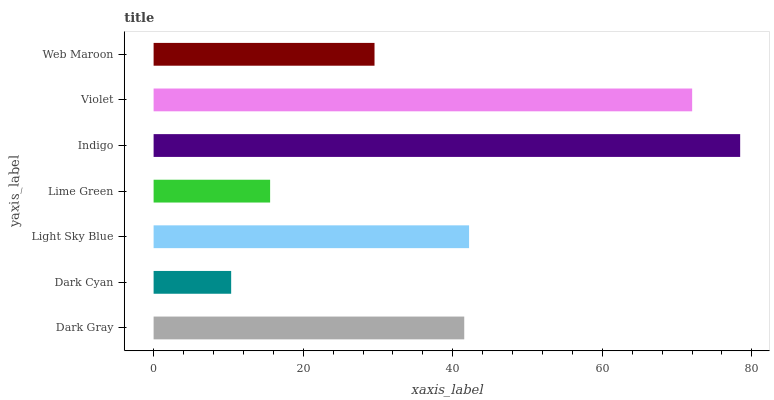Is Dark Cyan the minimum?
Answer yes or no. Yes. Is Indigo the maximum?
Answer yes or no. Yes. Is Light Sky Blue the minimum?
Answer yes or no. No. Is Light Sky Blue the maximum?
Answer yes or no. No. Is Light Sky Blue greater than Dark Cyan?
Answer yes or no. Yes. Is Dark Cyan less than Light Sky Blue?
Answer yes or no. Yes. Is Dark Cyan greater than Light Sky Blue?
Answer yes or no. No. Is Light Sky Blue less than Dark Cyan?
Answer yes or no. No. Is Dark Gray the high median?
Answer yes or no. Yes. Is Dark Gray the low median?
Answer yes or no. Yes. Is Violet the high median?
Answer yes or no. No. Is Web Maroon the low median?
Answer yes or no. No. 